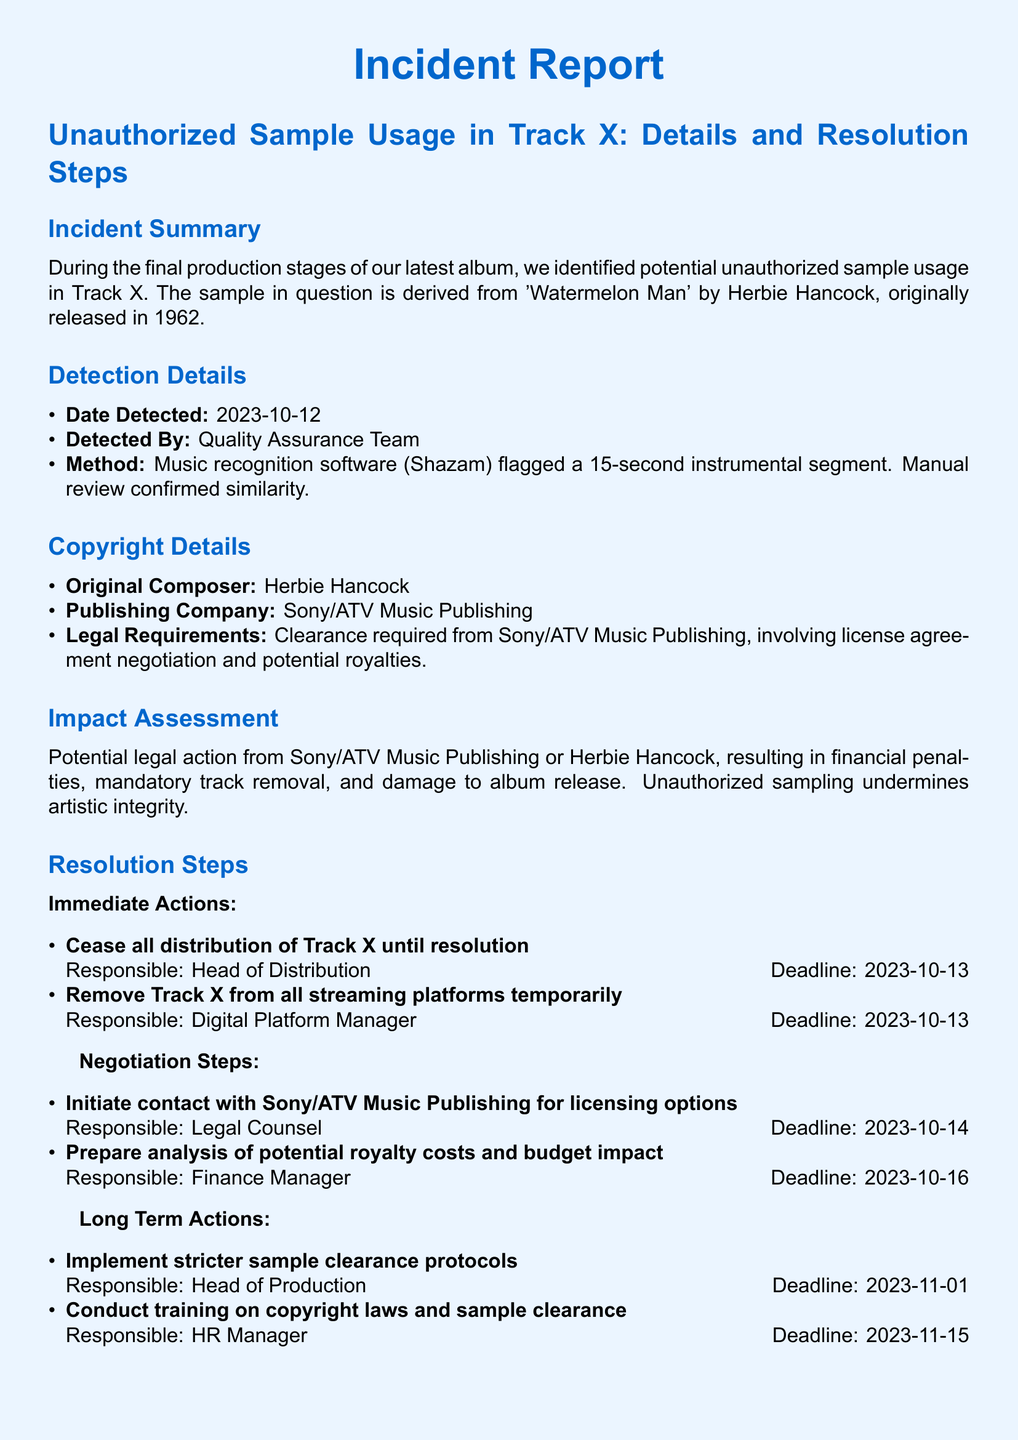What is the title of the reported incident? The title can be found in the section header of the document, which outlines the main focus of the report.
Answer: Unauthorized Sample Usage in Track X: Details and Resolution Steps Who detected the unauthorized sample usage? The detector is mentioned in the detection details, specifying the team that identified the issue.
Answer: Quality Assurance Team What date was the unauthorized sample detected? The detection date is expressly stated in the detection details section of the report.
Answer: 2023-10-12 What is the original song from which the sample was taken? The original song title is specified in the copyright details section, outlining the source of the sample issue.
Answer: Watermelon Man Who is responsible for contacting Sony/ATV Music Publishing? The resolution step lists the person tasked with this action under negotiation steps.
Answer: Legal Counsel What is the deadline for implementing stricter sample clearance protocols? The deadline is provided in the long term actions section, detailing the timing of the actions to be taken.
Answer: 2023-11-01 What is the potential consequence mentioned due to unauthorized sampling? The impact assessment details the possible repercussions related to the identified issue.
Answer: Financial penalties What is the publishing company associated with the original composition? The name of the publishing company is included in the copyright details section.
Answer: Sony/ATV Music Publishing What is the contact email for the Head of Legal Affairs? The contact email for the internal contact is provided in the contact information section.
Answer: jane.doe@musiccompany.com 